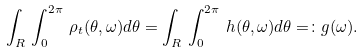<formula> <loc_0><loc_0><loc_500><loc_500>\int _ { R } \, \int ^ { 2 \pi } _ { 0 } \, \rho _ { t } ( \theta , \omega ) d \theta = \int _ { R } \, \int ^ { 2 \pi } _ { 0 } \, h ( \theta , \omega ) d \theta = \colon g ( \omega ) .</formula> 